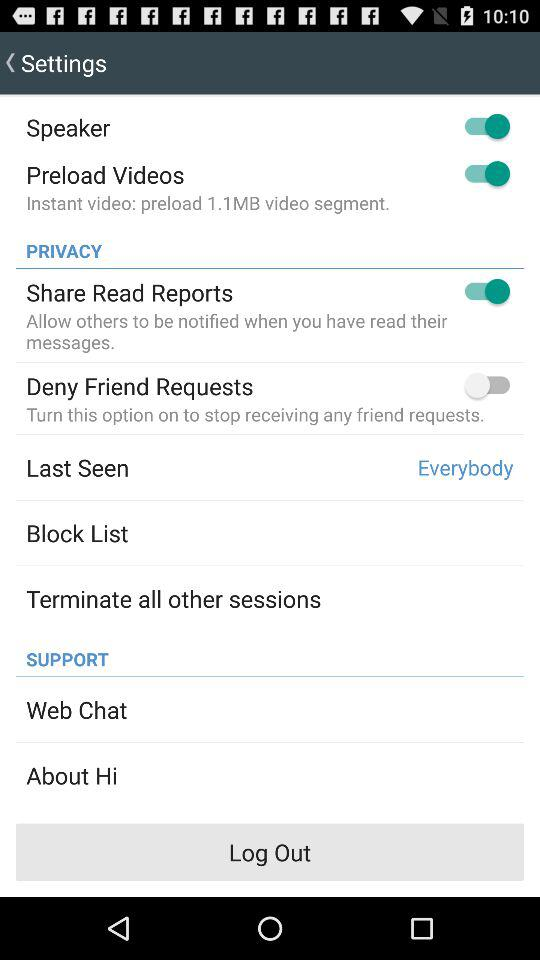How many items are in the privacy section that have a switch?
Answer the question using a single word or phrase. 2 